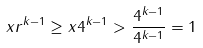Convert formula to latex. <formula><loc_0><loc_0><loc_500><loc_500>x r ^ { k - 1 } \geq x 4 ^ { k - 1 } > \frac { 4 ^ { k - 1 } } { 4 ^ { k - 1 } } = 1</formula> 